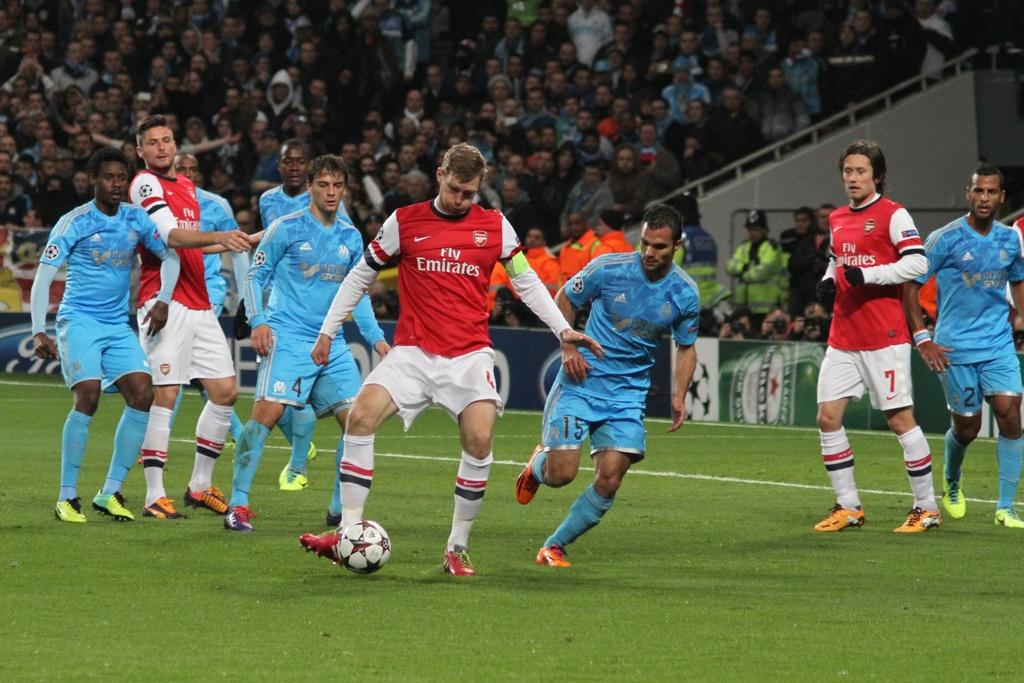<image>
Summarize the visual content of the image. A player wearing a red jersey that says Fly Emirates kicks the ball down the field 